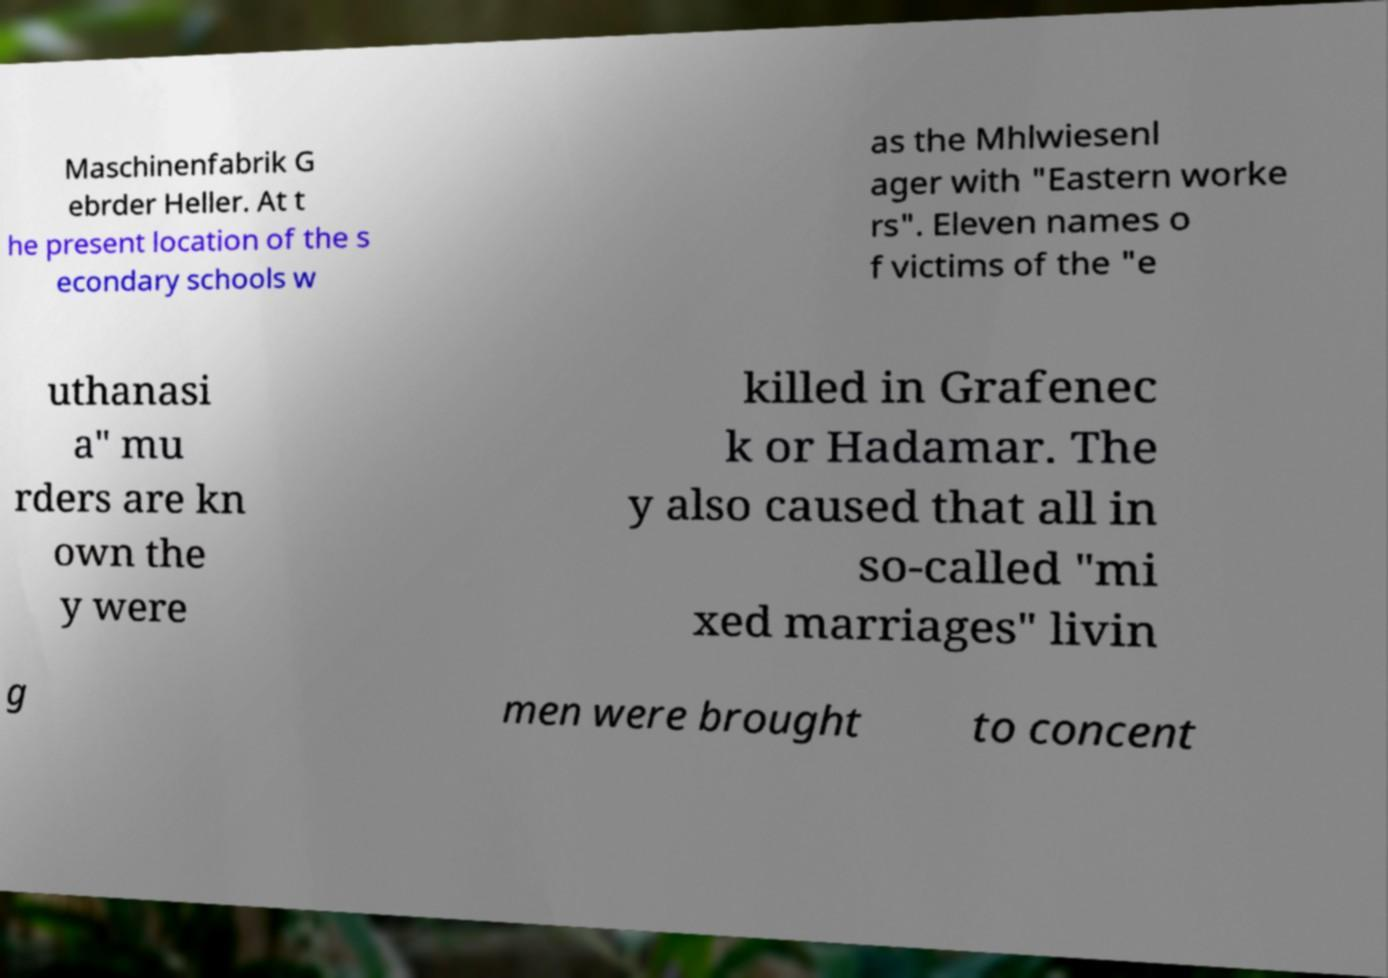Can you read and provide the text displayed in the image?This photo seems to have some interesting text. Can you extract and type it out for me? Maschinenfabrik G ebrder Heller. At t he present location of the s econdary schools w as the Mhlwiesenl ager with "Eastern worke rs". Eleven names o f victims of the "e uthanasi a" mu rders are kn own the y were killed in Grafenec k or Hadamar. The y also caused that all in so-called "mi xed marriages" livin g men were brought to concent 